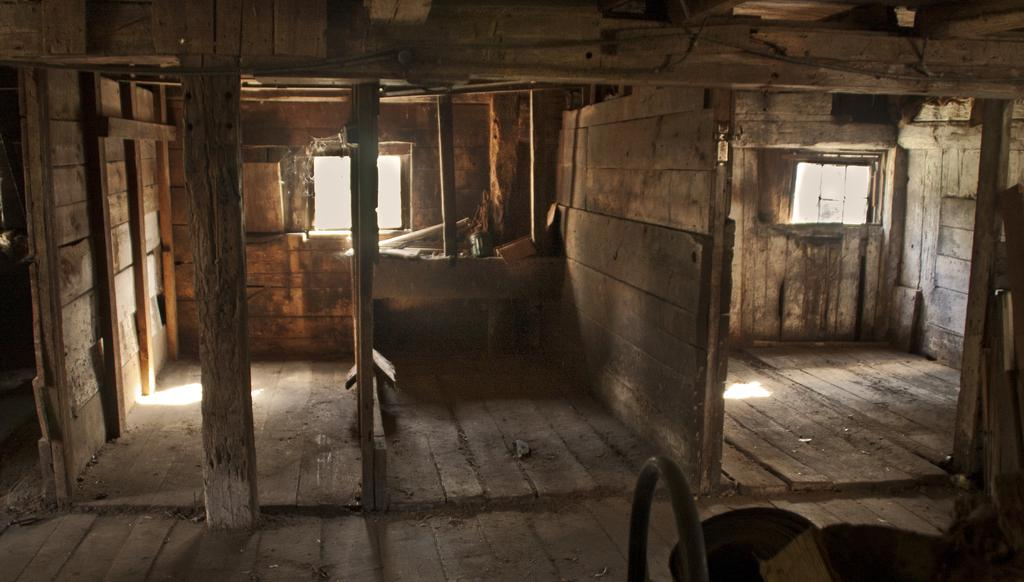What type of house is in the image? There is a wooden house in the image. What architectural feature can be seen in the image? There is a pillar in the image. What part of the house can be seen in the image? There is a window in the image. What structural element is present in the image? There is a wall in the image. What is the mind doing in the image? The mind is not a physical object that can be seen in the image. What time of day is depicted in the image? The time of day is not specified in the image, and it could be any time. 